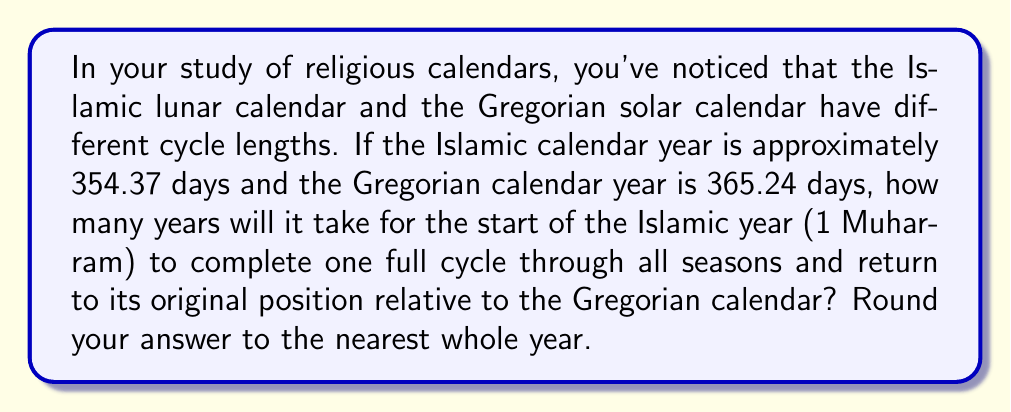Solve this math problem. To solve this problem, we need to understand the concept of the calendrical cycle and how it relates to the difference between the two calendar systems.

1. First, let's calculate the difference in days between the two calendar years:

   $365.24 - 354.37 = 10.87$ days

   This means that each year, the Islamic calendar shifts about 10.87 days earlier relative to the Gregorian calendar.

2. To complete one full cycle, the Islamic calendar needs to shift by a full 365.24 days (one complete Gregorian year). We can set up an equation:

   $365.24 = 10.87x$

   Where $x$ is the number of years it takes to complete the cycle.

3. Solving for $x$:

   $x = \frac{365.24}{10.87} \approx 33.60$ years

4. Rounding to the nearest whole year:

   $33.60$ rounds to $34$ years

This cycle is known as the Hijri-Gregorian cycle, which is crucial in understanding the relationship between these two calendrical systems used in different religious traditions.
Answer: 34 years 